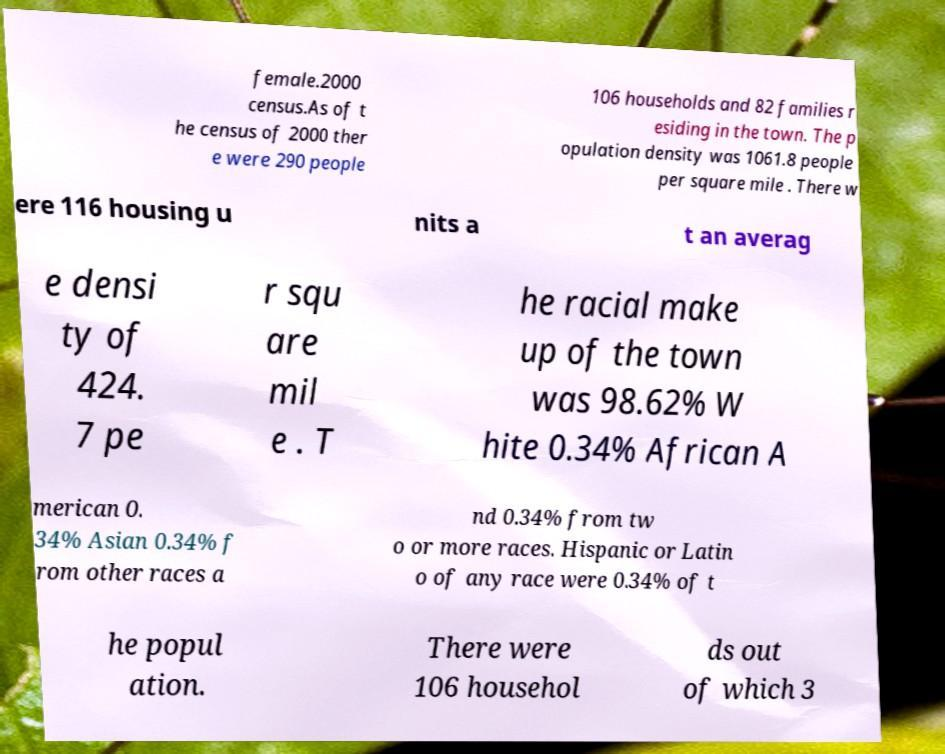Can you accurately transcribe the text from the provided image for me? female.2000 census.As of t he census of 2000 ther e were 290 people 106 households and 82 families r esiding in the town. The p opulation density was 1061.8 people per square mile . There w ere 116 housing u nits a t an averag e densi ty of 424. 7 pe r squ are mil e . T he racial make up of the town was 98.62% W hite 0.34% African A merican 0. 34% Asian 0.34% f rom other races a nd 0.34% from tw o or more races. Hispanic or Latin o of any race were 0.34% of t he popul ation. There were 106 househol ds out of which 3 